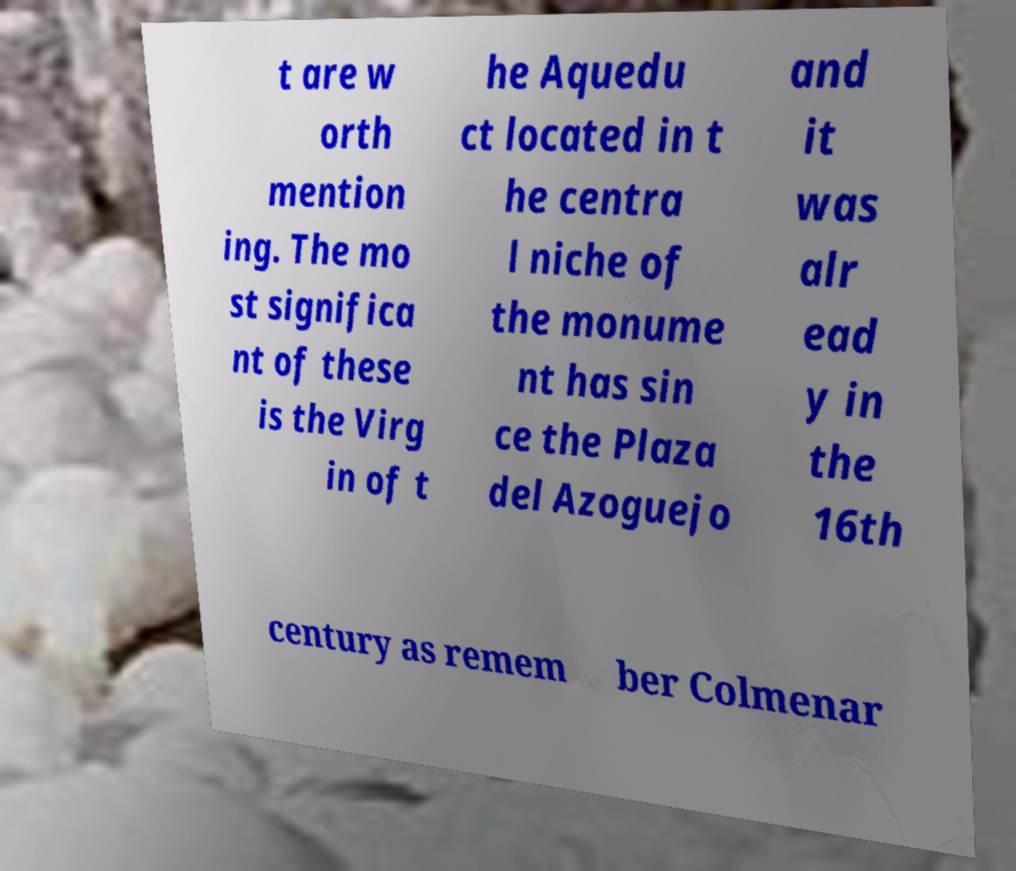There's text embedded in this image that I need extracted. Can you transcribe it verbatim? t are w orth mention ing. The mo st significa nt of these is the Virg in of t he Aquedu ct located in t he centra l niche of the monume nt has sin ce the Plaza del Azoguejo and it was alr ead y in the 16th century as remem ber Colmenar 